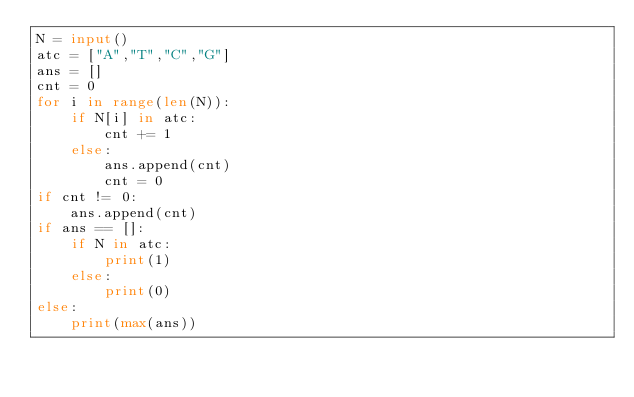<code> <loc_0><loc_0><loc_500><loc_500><_Python_>N = input()
atc = ["A","T","C","G"]
ans = []
cnt = 0
for i in range(len(N)):
    if N[i] in atc:
        cnt += 1
    else:
        ans.append(cnt)
        cnt = 0
if cnt != 0:
    ans.append(cnt)
if ans == []:
    if N in atc:
        print(1)
    else:
        print(0)
else:
    print(max(ans))</code> 